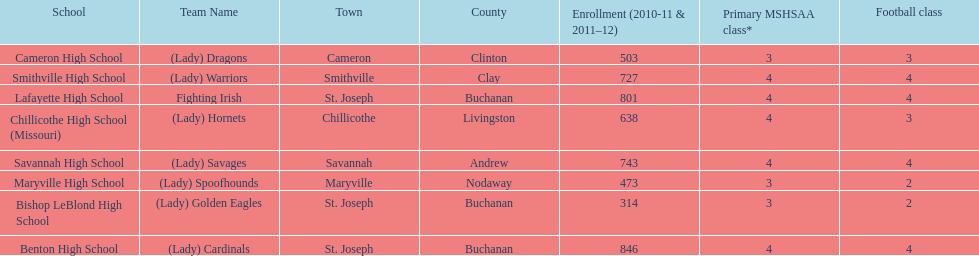Benton high school and bishop leblond high school are both located in what town? St. Joseph. 